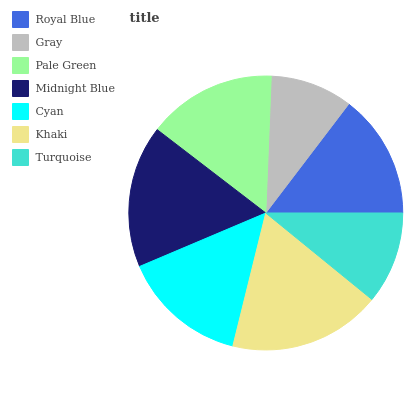Is Gray the minimum?
Answer yes or no. Yes. Is Khaki the maximum?
Answer yes or no. Yes. Is Pale Green the minimum?
Answer yes or no. No. Is Pale Green the maximum?
Answer yes or no. No. Is Pale Green greater than Gray?
Answer yes or no. Yes. Is Gray less than Pale Green?
Answer yes or no. Yes. Is Gray greater than Pale Green?
Answer yes or no. No. Is Pale Green less than Gray?
Answer yes or no. No. Is Cyan the high median?
Answer yes or no. Yes. Is Cyan the low median?
Answer yes or no. Yes. Is Khaki the high median?
Answer yes or no. No. Is Khaki the low median?
Answer yes or no. No. 